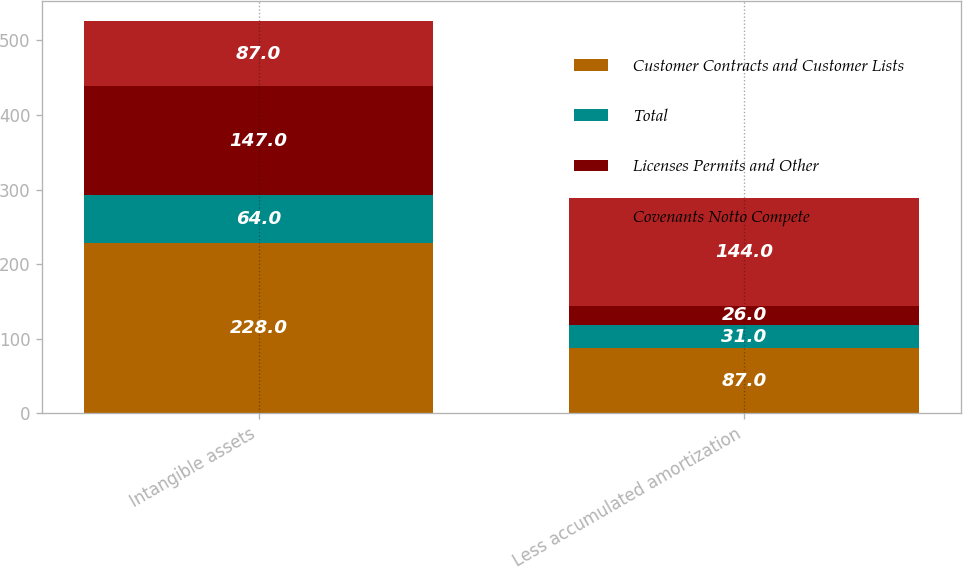Convert chart. <chart><loc_0><loc_0><loc_500><loc_500><stacked_bar_chart><ecel><fcel>Intangible assets<fcel>Less accumulated amortization<nl><fcel>Customer Contracts and Customer Lists<fcel>228<fcel>87<nl><fcel>Total<fcel>64<fcel>31<nl><fcel>Licenses Permits and Other<fcel>147<fcel>26<nl><fcel>Covenants Notto Compete<fcel>87<fcel>144<nl></chart> 